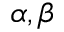<formula> <loc_0><loc_0><loc_500><loc_500>\alpha , \beta</formula> 